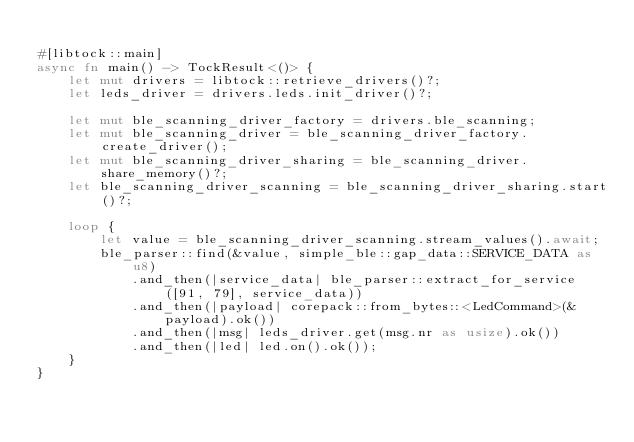<code> <loc_0><loc_0><loc_500><loc_500><_Rust_>
#[libtock::main]
async fn main() -> TockResult<()> {
    let mut drivers = libtock::retrieve_drivers()?;
    let leds_driver = drivers.leds.init_driver()?;

    let mut ble_scanning_driver_factory = drivers.ble_scanning;
    let mut ble_scanning_driver = ble_scanning_driver_factory.create_driver();
    let mut ble_scanning_driver_sharing = ble_scanning_driver.share_memory()?;
    let ble_scanning_driver_scanning = ble_scanning_driver_sharing.start()?;

    loop {
        let value = ble_scanning_driver_scanning.stream_values().await;
        ble_parser::find(&value, simple_ble::gap_data::SERVICE_DATA as u8)
            .and_then(|service_data| ble_parser::extract_for_service([91, 79], service_data))
            .and_then(|payload| corepack::from_bytes::<LedCommand>(&payload).ok())
            .and_then(|msg| leds_driver.get(msg.nr as usize).ok())
            .and_then(|led| led.on().ok());
    }
}
</code> 